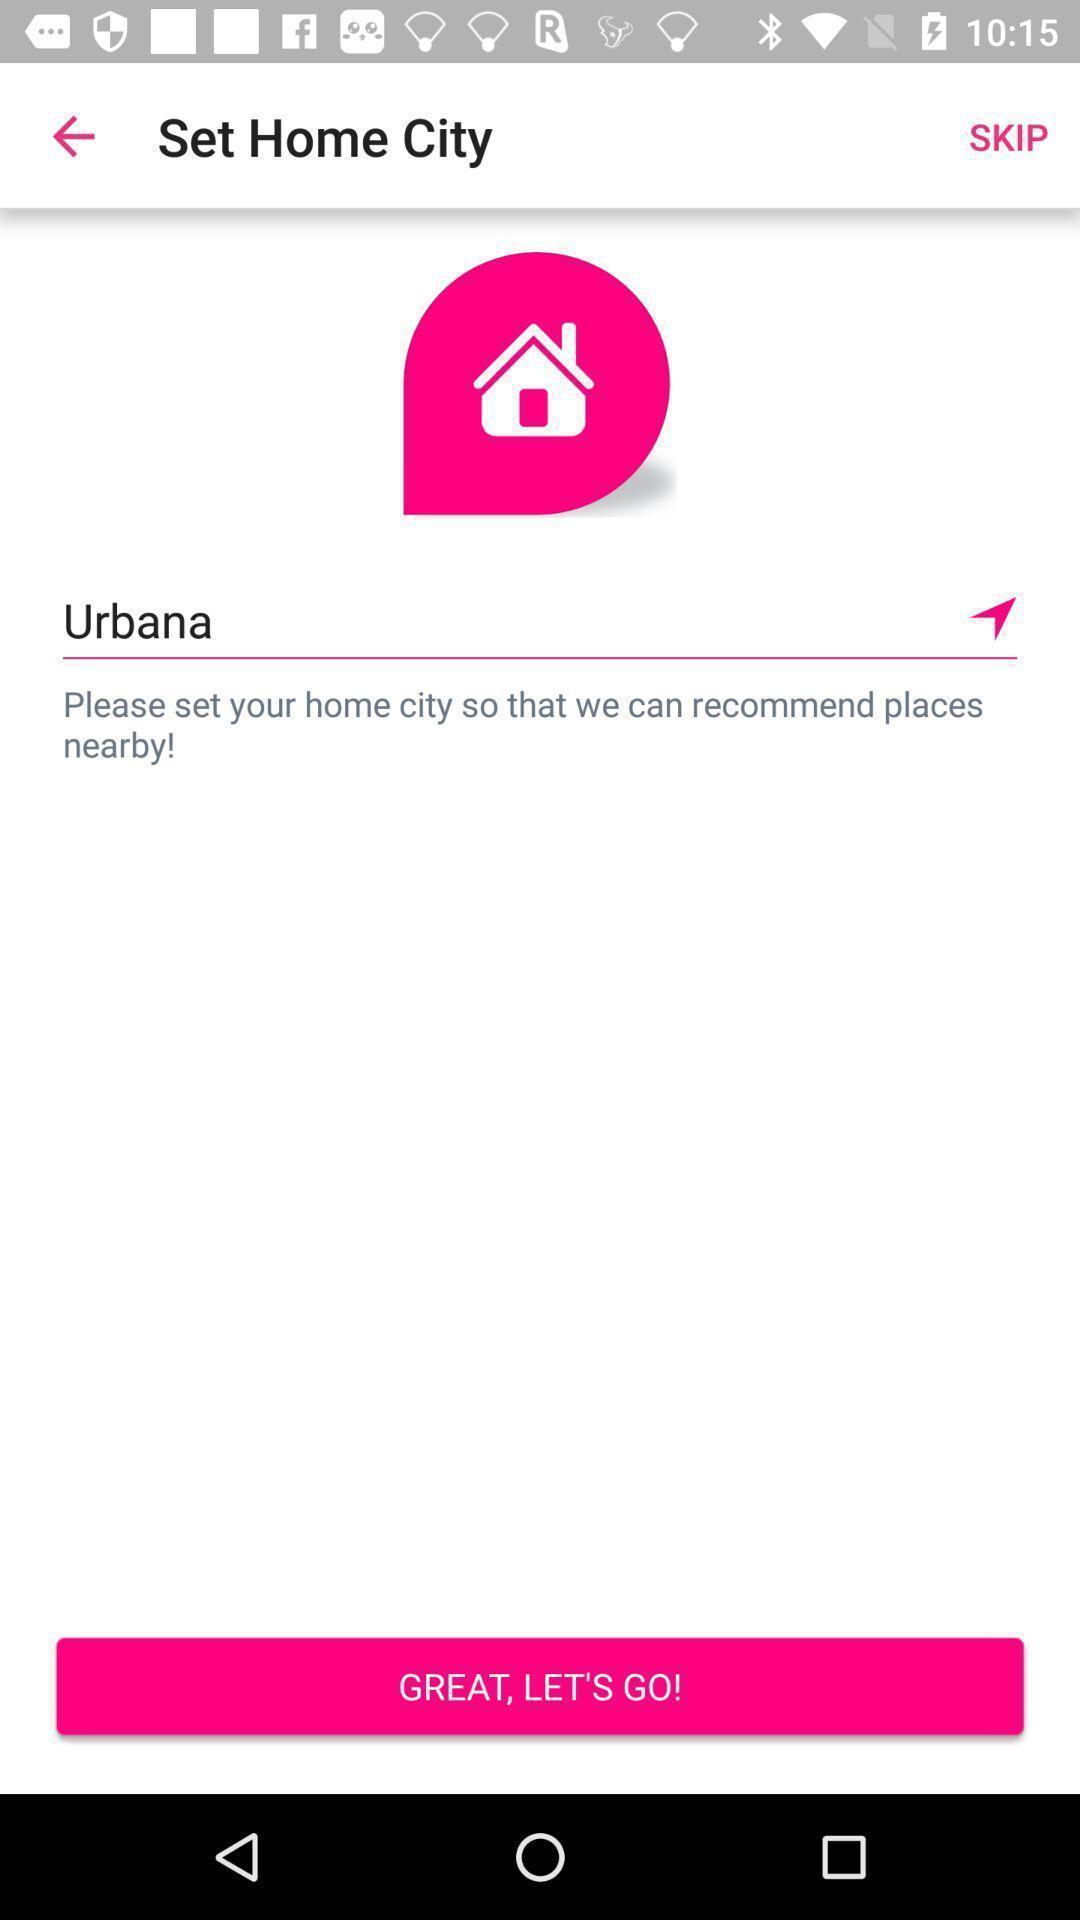Provide a textual representation of this image. Screen shows set home city name in a property app. 